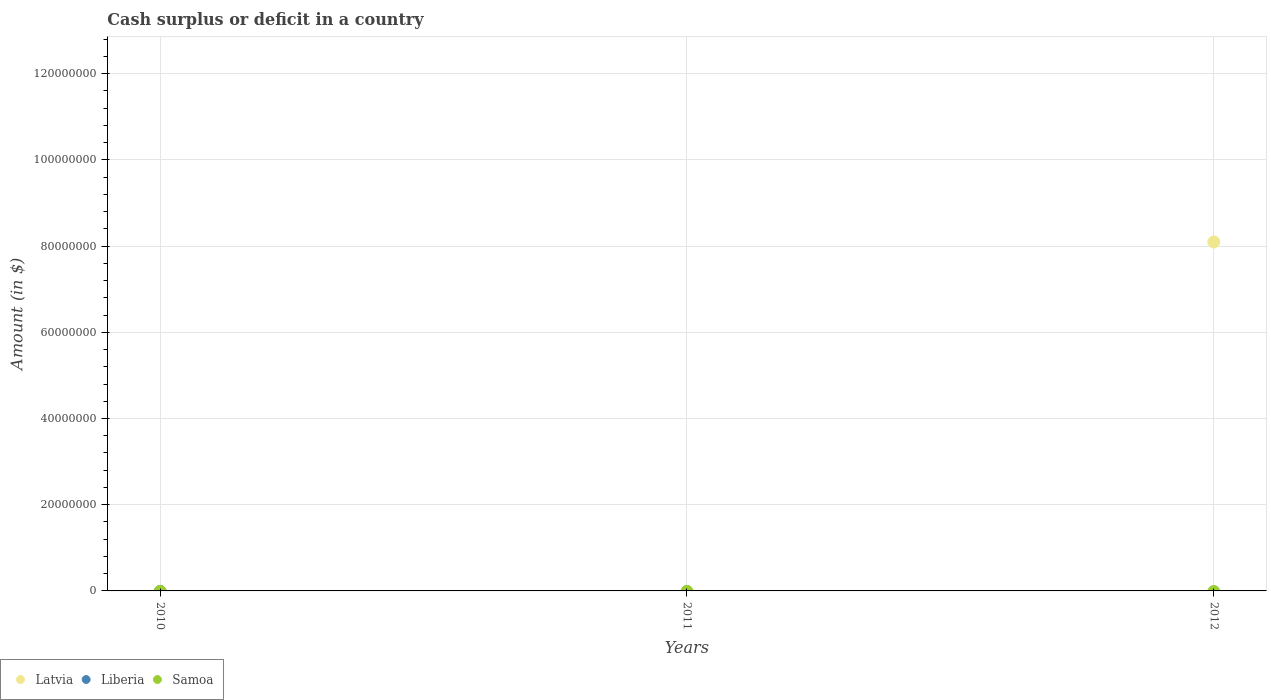How many different coloured dotlines are there?
Ensure brevity in your answer.  1. Is the number of dotlines equal to the number of legend labels?
Provide a succinct answer. No. What is the amount of cash surplus or deficit in Latvia in 2012?
Your answer should be compact. 8.09e+07. Across all years, what is the maximum amount of cash surplus or deficit in Latvia?
Give a very brief answer. 8.09e+07. Across all years, what is the minimum amount of cash surplus or deficit in Liberia?
Provide a succinct answer. 0. What is the total amount of cash surplus or deficit in Samoa in the graph?
Your answer should be very brief. 0. What is the difference between the highest and the lowest amount of cash surplus or deficit in Latvia?
Ensure brevity in your answer.  8.09e+07. Is it the case that in every year, the sum of the amount of cash surplus or deficit in Samoa and amount of cash surplus or deficit in Latvia  is greater than the amount of cash surplus or deficit in Liberia?
Keep it short and to the point. No. Is the amount of cash surplus or deficit in Latvia strictly greater than the amount of cash surplus or deficit in Samoa over the years?
Your answer should be compact. No. Is the amount of cash surplus or deficit in Samoa strictly less than the amount of cash surplus or deficit in Liberia over the years?
Your answer should be very brief. No. How many dotlines are there?
Give a very brief answer. 1. Are the values on the major ticks of Y-axis written in scientific E-notation?
Your response must be concise. No. Does the graph contain grids?
Offer a terse response. Yes. How many legend labels are there?
Offer a terse response. 3. How are the legend labels stacked?
Provide a succinct answer. Horizontal. What is the title of the graph?
Your response must be concise. Cash surplus or deficit in a country. What is the label or title of the Y-axis?
Provide a succinct answer. Amount (in $). What is the Amount (in $) in Latvia in 2010?
Keep it short and to the point. 0. What is the Amount (in $) in Liberia in 2010?
Give a very brief answer. 0. What is the Amount (in $) of Samoa in 2010?
Your response must be concise. 0. What is the Amount (in $) in Liberia in 2011?
Give a very brief answer. 0. What is the Amount (in $) of Latvia in 2012?
Give a very brief answer. 8.09e+07. Across all years, what is the maximum Amount (in $) of Latvia?
Your answer should be compact. 8.09e+07. What is the total Amount (in $) in Latvia in the graph?
Provide a succinct answer. 8.09e+07. What is the average Amount (in $) of Latvia per year?
Provide a short and direct response. 2.70e+07. What is the difference between the highest and the lowest Amount (in $) in Latvia?
Provide a short and direct response. 8.09e+07. 